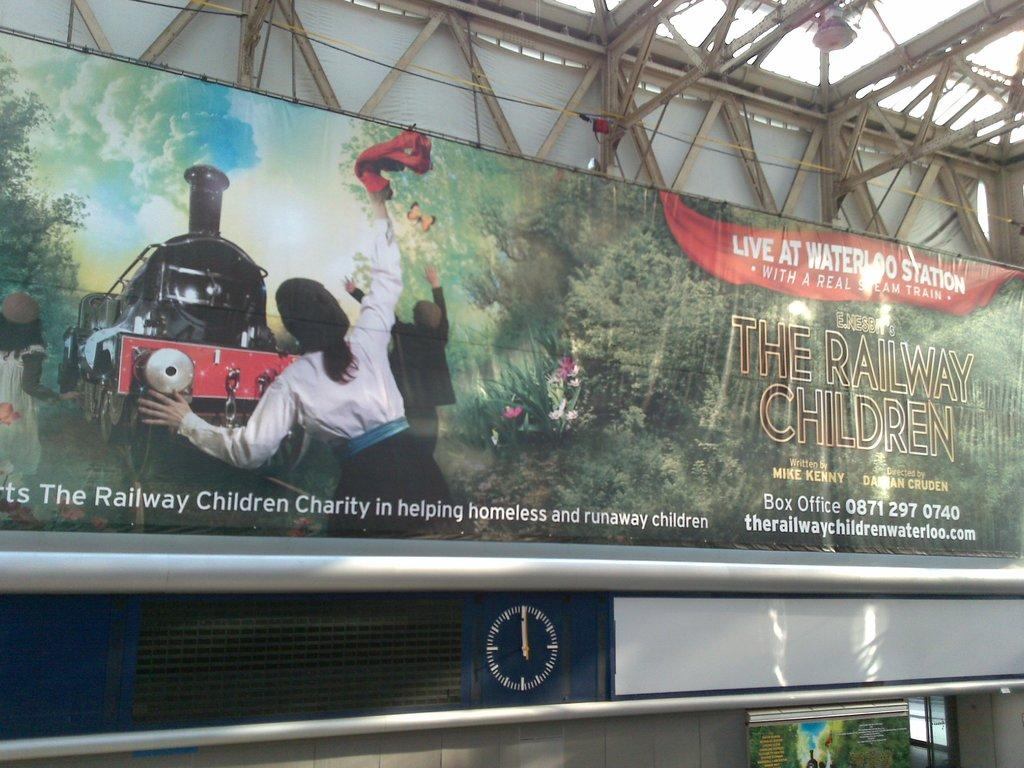<image>
Offer a succinct explanation of the picture presented. a sign for a event at the Waterloo Station 